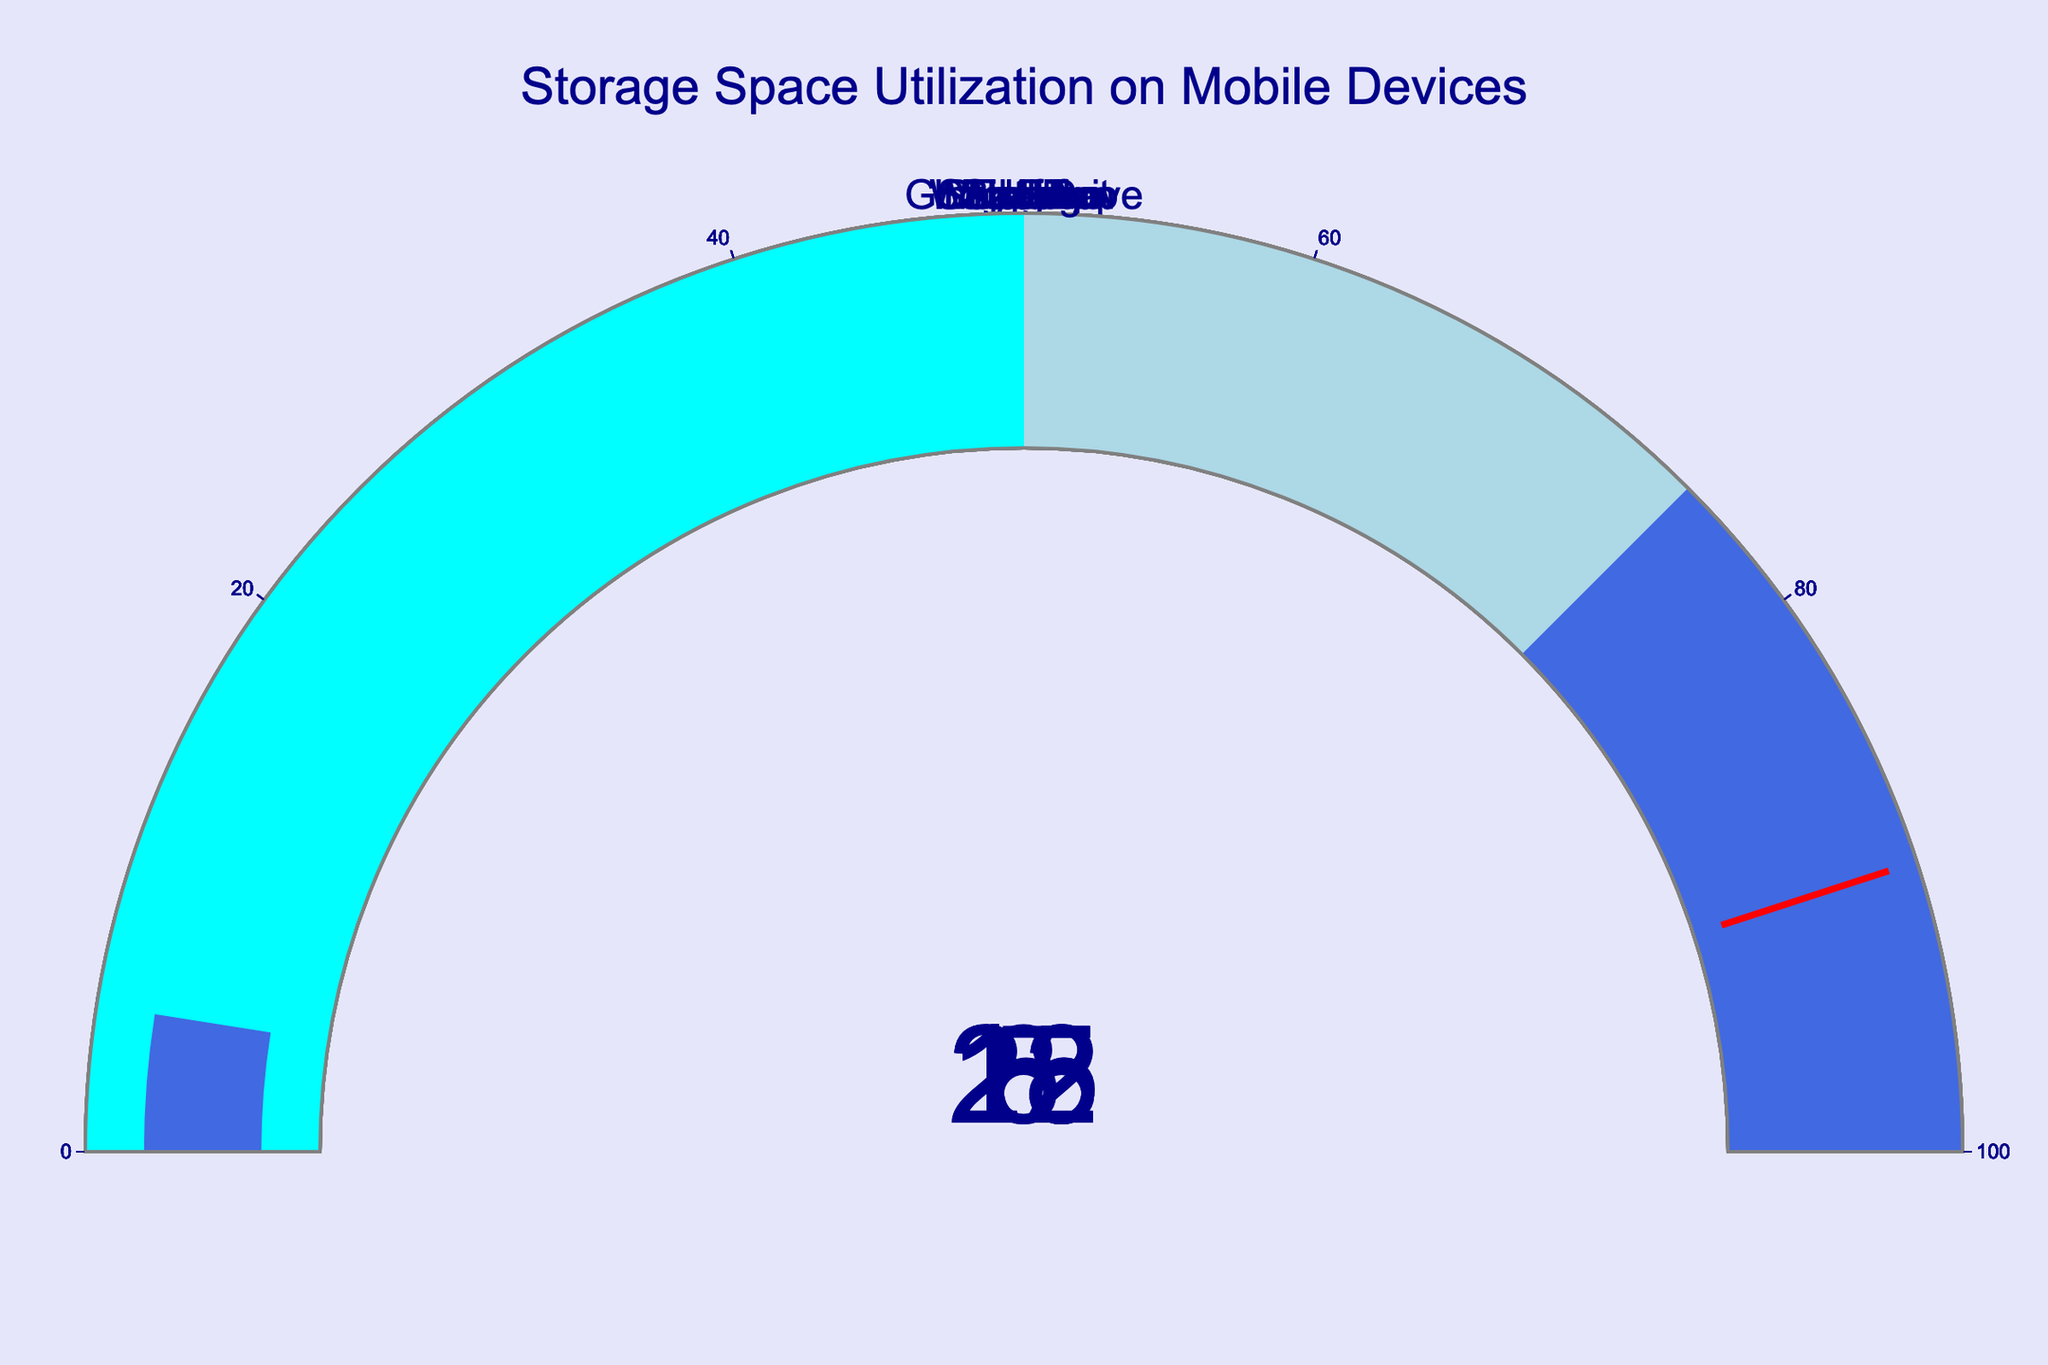Which app has the highest percentage of storage utilization? The highest value on the gauge charts is 28 for Instagram.
Answer: Instagram What is the total percentage of storage utilized by TikTok and Netflix combined? TikTok utilises 25% and Netflix utilises 12%. Adding these values together, 25 + 12 = 37.
Answer: 37% Which app uses less storage, WhatsApp or Spotify? Comparing the values, WhatsApp uses 18% and Spotify uses 15%. Since 15 < 18, Spotify uses less storage.
Answer: Spotify Between Google Drive, TikTok, and Netflix, which one has the smallest percentage of storage utilization? The values for Google Drive, TikTok, and Netflix are 22%, 25%, and 12%, respectively. The smallest of these values is 12% for Netflix.
Answer: Netflix What is the average storage utilization across all the apps shown? Sum all the percentages: 28 + 15 + 22 + 18 + 25 + 12 + 8 + 5 = 133. There are 8 apps in total. The average is 133 / 8 = 16.625.
Answer: 16.625% How much more storage does Instagram use compared to Snapchat? Instagram uses 28% and Snapchat uses 8%. The difference is 28 - 8 = 20.
Answer: 20% Which apps use more than 20% of storage each? Evaluating the percentages, Instagram (28%), Google Drive (22%), and TikTok (25%) each use more than 20% of storage.
Answer: Instagram, Google Drive, TikTok What are the percentages of storage utilization for applications building the median storage usage? Arrange the percentages in ascending order: 5, 8, 12, 15, 18, 22, 25, 28. The median is the average of the middle values 15 and 18. Their median is (15 + 18) / 2 = 16.5.
Answer: 16.5% 